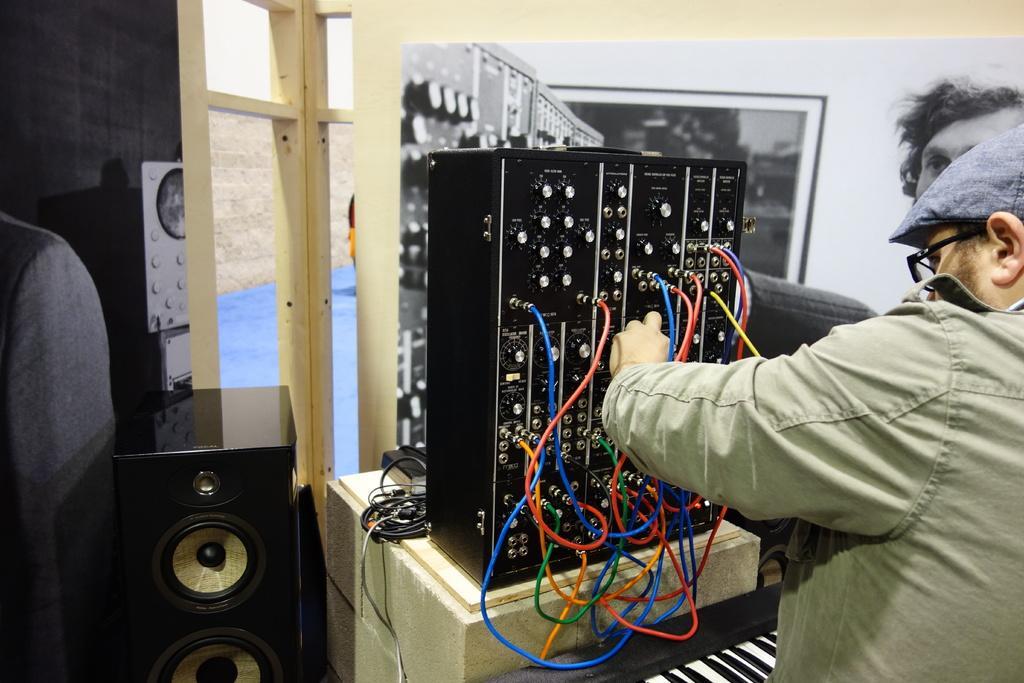In one or two sentences, can you explain what this image depicts? In this image I can see a person wearing green colored dress is standing and holding an object. I can see few colorful wires, few electronic devices, a speaker and in the background I can see the cream colored wall, a poster attached to the wall and the window. 